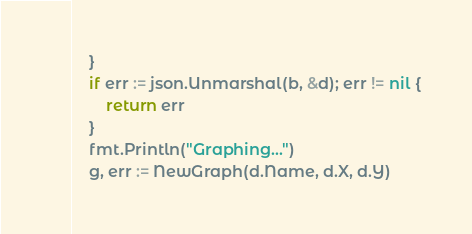Convert code to text. <code><loc_0><loc_0><loc_500><loc_500><_Go_>	}
	if err := json.Unmarshal(b, &d); err != nil {
		return err
	}
	fmt.Println("Graphing...")
	g, err := NewGraph(d.Name, d.X, d.Y)</code> 